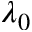Convert formula to latex. <formula><loc_0><loc_0><loc_500><loc_500>\lambda _ { 0 }</formula> 